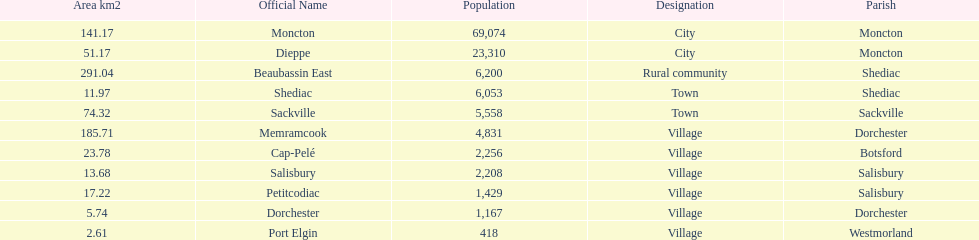City in the same parish of moncton Dieppe. 